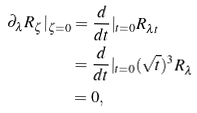Convert formula to latex. <formula><loc_0><loc_0><loc_500><loc_500>\partial _ { \lambda } R _ { \zeta } | _ { \zeta = 0 } & = \frac { d } { d t } | _ { t = 0 } R _ { \lambda t } \\ & = \frac { d } { d t } | _ { t = 0 } ( \sqrt { t } ) ^ { 3 } R _ { \lambda } \\ & = 0 ,</formula> 